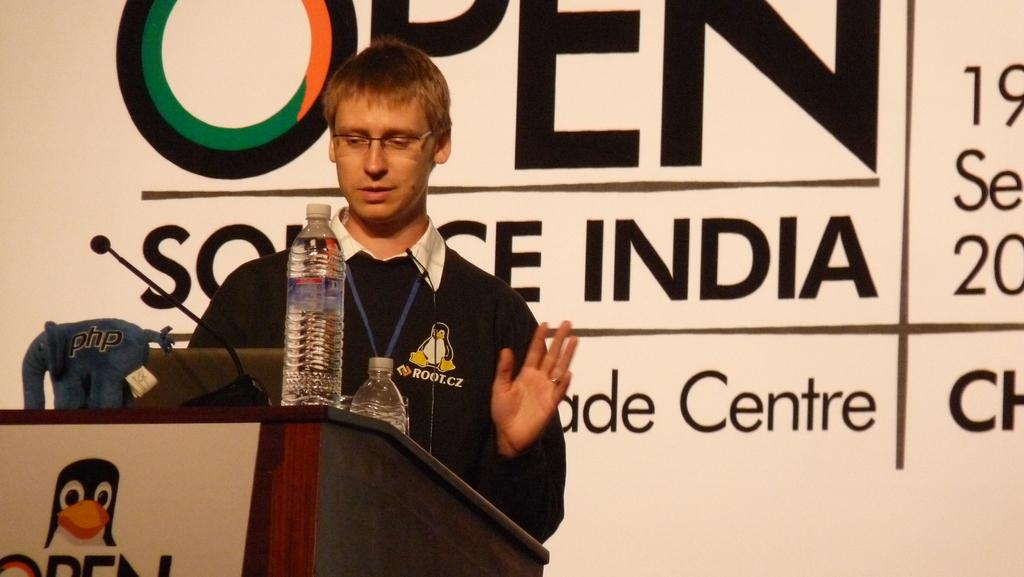Provide a one-sentence caption for the provided image. A person giving a lecture at Open Source India. 